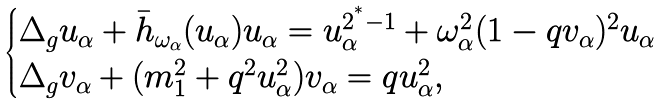<formula> <loc_0><loc_0><loc_500><loc_500>\begin{cases} \Delta _ { g } u _ { \alpha } + \bar { h } _ { \omega _ { \alpha } } ( u _ { \alpha } ) u _ { \alpha } = u _ { \alpha } ^ { 2 ^ { ^ { * } } - 1 } + \omega _ { \alpha } ^ { 2 } ( 1 - q v _ { \alpha } ) ^ { 2 } u _ { \alpha } \\ \Delta _ { g } v _ { \alpha } + ( m _ { 1 } ^ { 2 } + q ^ { 2 } u _ { \alpha } ^ { 2 } ) v _ { \alpha } = q u _ { \alpha } ^ { 2 } , \end{cases}</formula> 